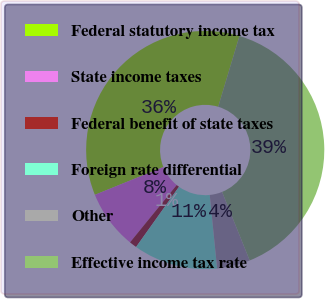Convert chart to OTSL. <chart><loc_0><loc_0><loc_500><loc_500><pie_chart><fcel>Federal statutory income tax<fcel>State income taxes<fcel>Federal benefit of state taxes<fcel>Foreign rate differential<fcel>Other<fcel>Effective income tax rate<nl><fcel>35.79%<fcel>7.98%<fcel>1.02%<fcel>11.45%<fcel>4.5%<fcel>39.26%<nl></chart> 